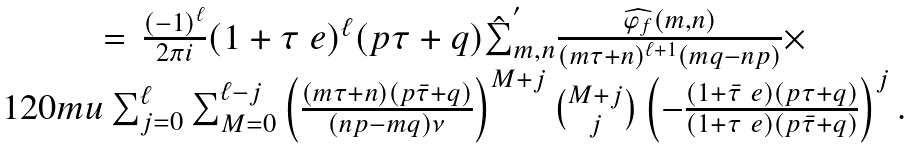Convert formula to latex. <formula><loc_0><loc_0><loc_500><loc_500>\begin{matrix} = \, \frac { ( - 1 ) ^ { \ell } } { 2 \pi i } ( 1 + \tau \ e ) ^ { \ell } ( p \tau + q ) \hat { \sum } _ { m , n } ^ { ^ { \prime } } \frac { \widehat { \varphi _ { f } } ( m , n ) } { ( m \tau + n ) ^ { \ell + 1 } ( m q - n p ) } \times \\ { 1 2 0 m u } \sum _ { j = 0 } ^ { \ell } \sum _ { M = 0 } ^ { \ell - j } \left ( \frac { ( m \tau + n ) ( p \bar { \tau } + q ) } { ( n p - m q ) \nu } \right ) ^ { M + j } \binom { M + j } { j } \left ( - \frac { ( 1 + \bar { \tau } \ e ) ( p \tau + q ) } { ( 1 + \tau \ e ) ( p \bar { \tau } + q ) } \right ) ^ { j } . \end{matrix} \\</formula> 